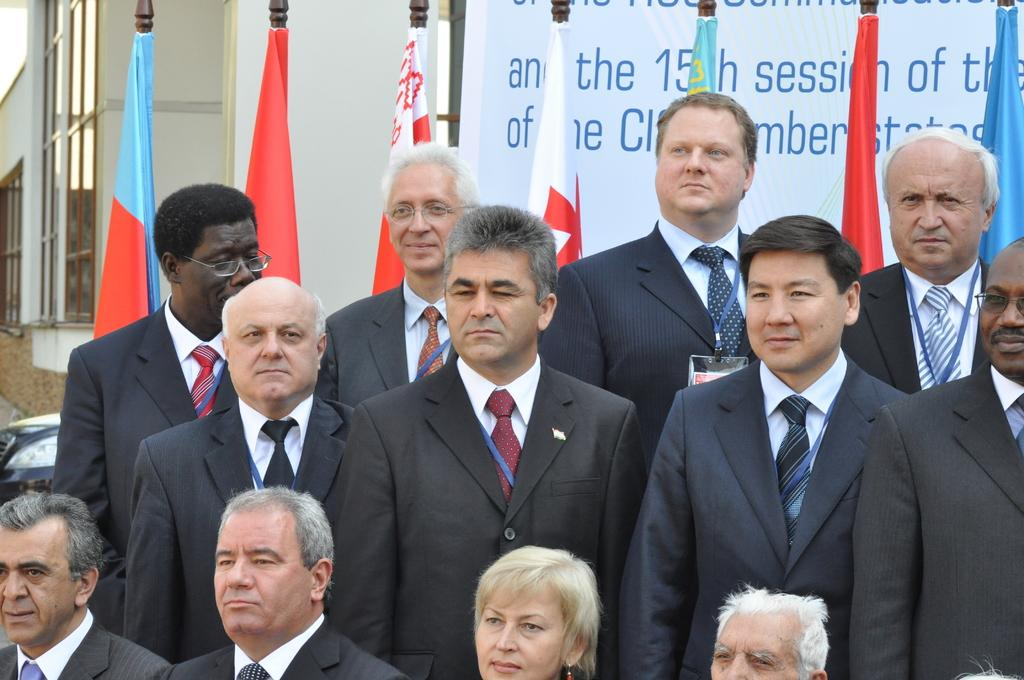What is happening in the bottom of the image? There are persons standing in the bottom of the image. What can be seen in the background of the image? There is a building in the background of the image. What is located at the top of the image? There are flags on the top of the image. What type of thread is being used by the persons in the image? There is no thread visible in the image, and the persons are not shown using any thread. Can you hear the sound of the flags flapping in the image? The image is static, so it does not convey any sound, including the sound of flags flapping. 